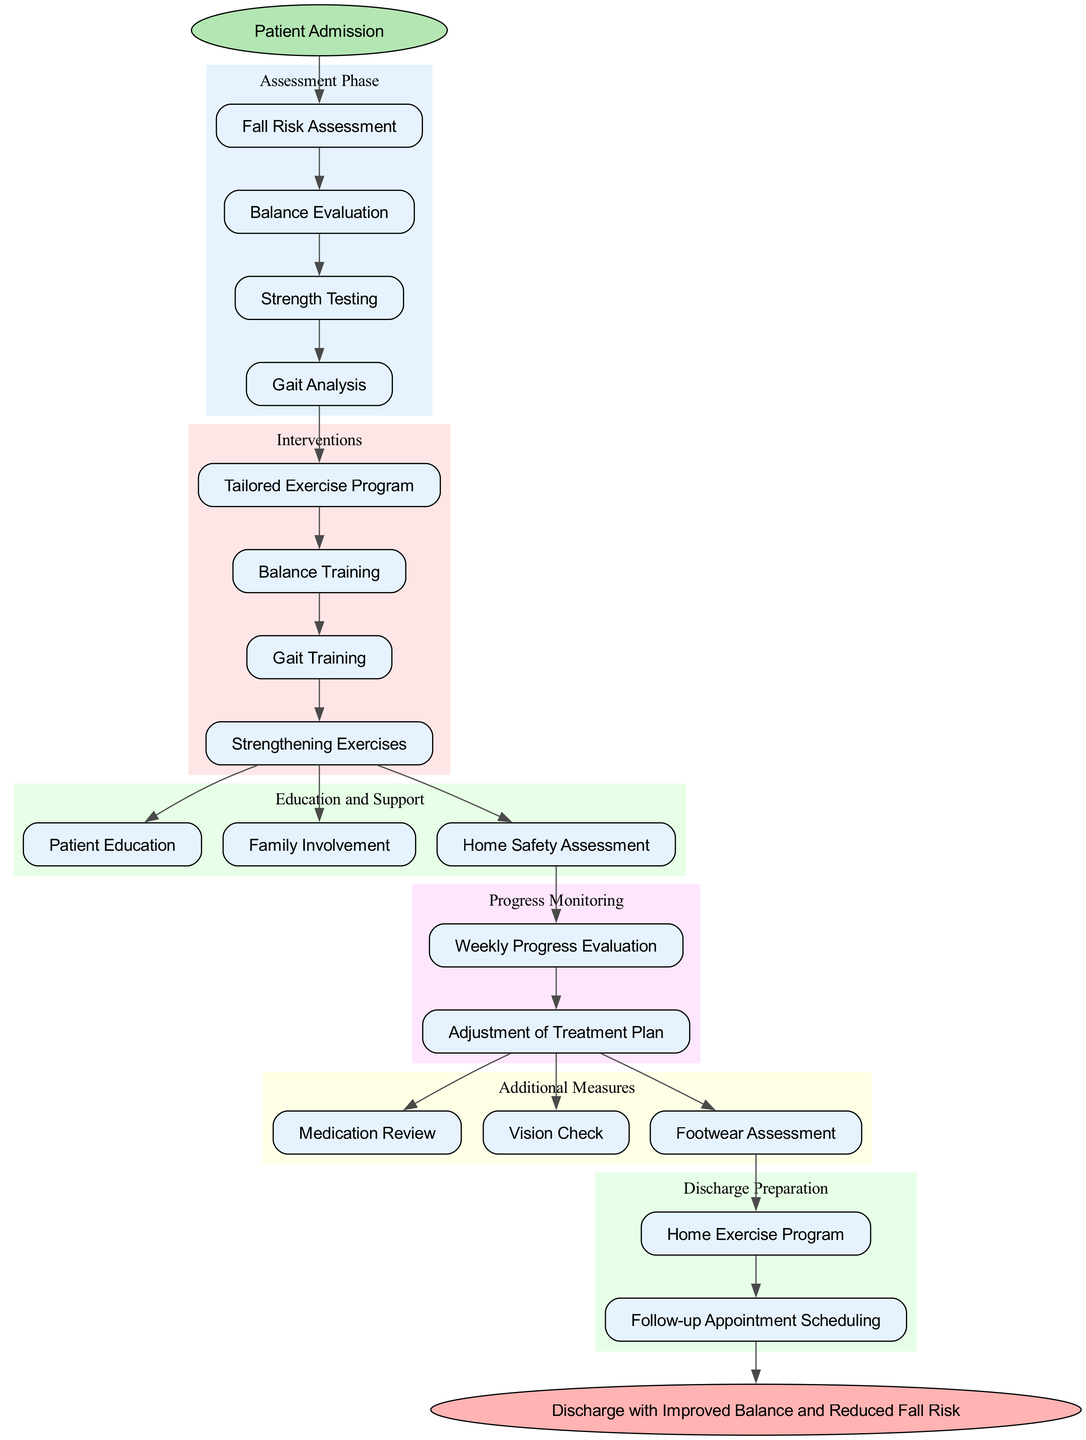What is the starting point of the clinical pathway? The starting point node in the diagram is labeled "Patient Admission." This indicates where the entire clinical pathway begins, guiding the flow of the process for elderly patients.
Answer: Patient Admission How many stages are there in the assessment phase? The assessment phase includes four distinct nodes: "Fall Risk Assessment," "Balance Evaluation," "Strength Testing," and "Gait Analysis." By counting these nodes, we find there are four stages.
Answer: 4 Which intervention follows "Balance Training"? The diagram shows that "Gait Training" comes directly after "Balance Training" in the intervention phase, indicating the order in which these interventions are arranged for patients.
Answer: Gait Training What is the last step before discharge preparation? The last intervention noted before discharge preparation is "Strengthening Exercises." This is a critical step that precedes the preparation for a patient's discharge.
Answer: Strengthening Exercises What type of assessment is included in the additional measures? One of the nodes in the additional measures section is labeled "Vision Check." This indicates that assessing vision is part of the measures taken to reduce fall risk.
Answer: Vision Check Which phase includes "Family Involvement"? "Family Involvement" is part of the education and support phase in the diagram. This phase emphasizes the importance of including family members in the rehabilitation process for better outcomes.
Answer: Education and Support How is progress monitored in the clinical pathway? The progress monitoring section of the diagram includes "Weekly Progress Evaluation" and "Adjustment of Treatment Plan," which are designed to track the patient's recovery and modify treatment as needed.
Answer: Weekly Progress Evaluation, Adjustment of Treatment Plan What is the endpoint of the clinical pathway? The endpoint of the clinical pathway is denoted as "Discharge with Improved Balance and Reduced Fall Risk." This indicates the ultimate goal of the intervention process for the elderly patients.
Answer: Discharge with Improved Balance and Reduced Fall Risk 